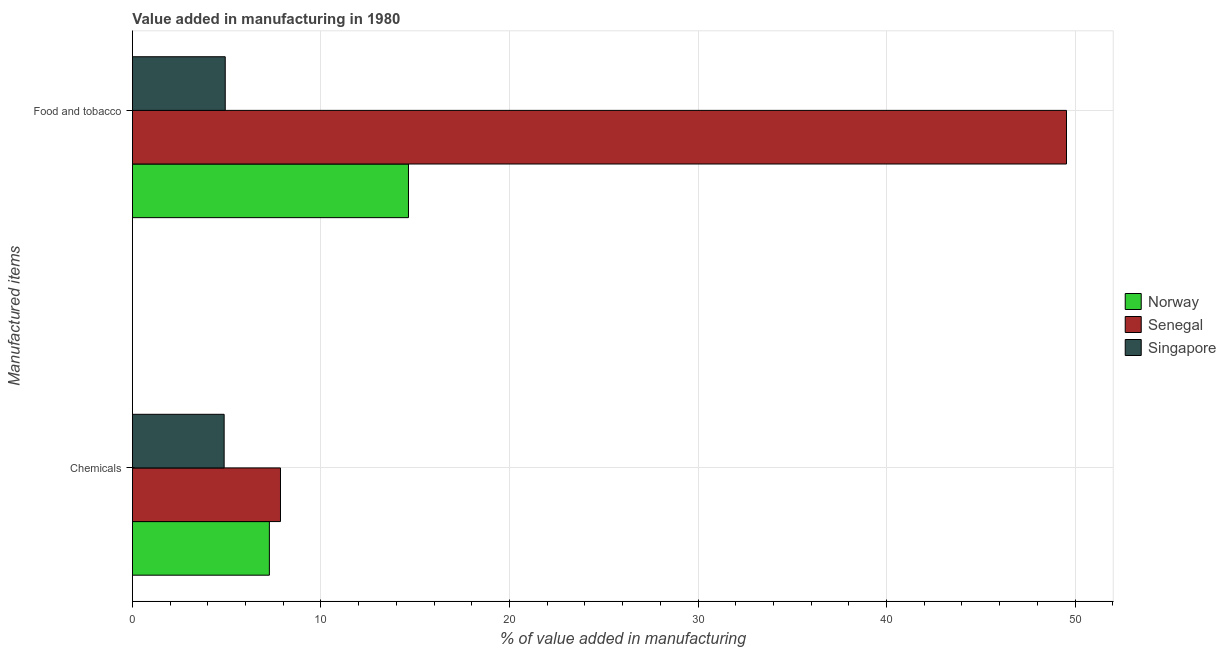How many groups of bars are there?
Your answer should be compact. 2. Are the number of bars per tick equal to the number of legend labels?
Give a very brief answer. Yes. What is the label of the 1st group of bars from the top?
Your answer should be compact. Food and tobacco. What is the value added by  manufacturing chemicals in Senegal?
Keep it short and to the point. 7.85. Across all countries, what is the maximum value added by manufacturing food and tobacco?
Provide a succinct answer. 49.54. Across all countries, what is the minimum value added by manufacturing food and tobacco?
Give a very brief answer. 4.92. In which country was the value added by  manufacturing chemicals maximum?
Ensure brevity in your answer.  Senegal. In which country was the value added by  manufacturing chemicals minimum?
Make the answer very short. Singapore. What is the total value added by manufacturing food and tobacco in the graph?
Offer a terse response. 69.11. What is the difference between the value added by  manufacturing chemicals in Senegal and that in Norway?
Provide a succinct answer. 0.59. What is the difference between the value added by manufacturing food and tobacco in Norway and the value added by  manufacturing chemicals in Singapore?
Your answer should be compact. 9.78. What is the average value added by  manufacturing chemicals per country?
Your response must be concise. 6.66. What is the difference between the value added by  manufacturing chemicals and value added by manufacturing food and tobacco in Norway?
Provide a succinct answer. -7.38. In how many countries, is the value added by manufacturing food and tobacco greater than 16 %?
Make the answer very short. 1. What is the ratio of the value added by  manufacturing chemicals in Singapore to that in Senegal?
Make the answer very short. 0.62. Is the value added by manufacturing food and tobacco in Norway less than that in Senegal?
Make the answer very short. Yes. What does the 2nd bar from the top in Food and tobacco represents?
Keep it short and to the point. Senegal. What does the 3rd bar from the bottom in Food and tobacco represents?
Your answer should be very brief. Singapore. How many bars are there?
Your response must be concise. 6. Are all the bars in the graph horizontal?
Make the answer very short. Yes. How many countries are there in the graph?
Provide a short and direct response. 3. What is the difference between two consecutive major ticks on the X-axis?
Provide a succinct answer. 10. Are the values on the major ticks of X-axis written in scientific E-notation?
Keep it short and to the point. No. Does the graph contain grids?
Provide a short and direct response. Yes. Where does the legend appear in the graph?
Provide a short and direct response. Center right. What is the title of the graph?
Make the answer very short. Value added in manufacturing in 1980. Does "St. Martin (French part)" appear as one of the legend labels in the graph?
Provide a short and direct response. No. What is the label or title of the X-axis?
Provide a short and direct response. % of value added in manufacturing. What is the label or title of the Y-axis?
Your answer should be very brief. Manufactured items. What is the % of value added in manufacturing in Norway in Chemicals?
Offer a terse response. 7.26. What is the % of value added in manufacturing in Senegal in Chemicals?
Ensure brevity in your answer.  7.85. What is the % of value added in manufacturing in Singapore in Chemicals?
Offer a very short reply. 4.86. What is the % of value added in manufacturing in Norway in Food and tobacco?
Give a very brief answer. 14.64. What is the % of value added in manufacturing in Senegal in Food and tobacco?
Provide a short and direct response. 49.54. What is the % of value added in manufacturing of Singapore in Food and tobacco?
Provide a succinct answer. 4.92. Across all Manufactured items, what is the maximum % of value added in manufacturing of Norway?
Your answer should be compact. 14.64. Across all Manufactured items, what is the maximum % of value added in manufacturing of Senegal?
Make the answer very short. 49.54. Across all Manufactured items, what is the maximum % of value added in manufacturing of Singapore?
Your answer should be compact. 4.92. Across all Manufactured items, what is the minimum % of value added in manufacturing in Norway?
Your response must be concise. 7.26. Across all Manufactured items, what is the minimum % of value added in manufacturing in Senegal?
Your answer should be very brief. 7.85. Across all Manufactured items, what is the minimum % of value added in manufacturing of Singapore?
Make the answer very short. 4.86. What is the total % of value added in manufacturing in Norway in the graph?
Offer a terse response. 21.9. What is the total % of value added in manufacturing of Senegal in the graph?
Ensure brevity in your answer.  57.4. What is the total % of value added in manufacturing in Singapore in the graph?
Make the answer very short. 9.79. What is the difference between the % of value added in manufacturing of Norway in Chemicals and that in Food and tobacco?
Give a very brief answer. -7.38. What is the difference between the % of value added in manufacturing in Senegal in Chemicals and that in Food and tobacco?
Keep it short and to the point. -41.69. What is the difference between the % of value added in manufacturing of Singapore in Chemicals and that in Food and tobacco?
Keep it short and to the point. -0.06. What is the difference between the % of value added in manufacturing of Norway in Chemicals and the % of value added in manufacturing of Senegal in Food and tobacco?
Provide a succinct answer. -42.28. What is the difference between the % of value added in manufacturing in Norway in Chemicals and the % of value added in manufacturing in Singapore in Food and tobacco?
Offer a terse response. 2.34. What is the difference between the % of value added in manufacturing of Senegal in Chemicals and the % of value added in manufacturing of Singapore in Food and tobacco?
Make the answer very short. 2.93. What is the average % of value added in manufacturing in Norway per Manufactured items?
Make the answer very short. 10.95. What is the average % of value added in manufacturing in Senegal per Manufactured items?
Offer a very short reply. 28.7. What is the average % of value added in manufacturing in Singapore per Manufactured items?
Your answer should be very brief. 4.89. What is the difference between the % of value added in manufacturing in Norway and % of value added in manufacturing in Senegal in Chemicals?
Offer a very short reply. -0.59. What is the difference between the % of value added in manufacturing of Norway and % of value added in manufacturing of Singapore in Chemicals?
Keep it short and to the point. 2.4. What is the difference between the % of value added in manufacturing of Senegal and % of value added in manufacturing of Singapore in Chemicals?
Your answer should be very brief. 2.99. What is the difference between the % of value added in manufacturing in Norway and % of value added in manufacturing in Senegal in Food and tobacco?
Give a very brief answer. -34.9. What is the difference between the % of value added in manufacturing of Norway and % of value added in manufacturing of Singapore in Food and tobacco?
Offer a very short reply. 9.72. What is the difference between the % of value added in manufacturing of Senegal and % of value added in manufacturing of Singapore in Food and tobacco?
Your response must be concise. 44.62. What is the ratio of the % of value added in manufacturing of Norway in Chemicals to that in Food and tobacco?
Offer a terse response. 0.5. What is the ratio of the % of value added in manufacturing of Senegal in Chemicals to that in Food and tobacco?
Make the answer very short. 0.16. What is the ratio of the % of value added in manufacturing of Singapore in Chemicals to that in Food and tobacco?
Keep it short and to the point. 0.99. What is the difference between the highest and the second highest % of value added in manufacturing in Norway?
Your answer should be very brief. 7.38. What is the difference between the highest and the second highest % of value added in manufacturing of Senegal?
Your answer should be very brief. 41.69. What is the difference between the highest and the second highest % of value added in manufacturing of Singapore?
Give a very brief answer. 0.06. What is the difference between the highest and the lowest % of value added in manufacturing in Norway?
Provide a short and direct response. 7.38. What is the difference between the highest and the lowest % of value added in manufacturing of Senegal?
Offer a very short reply. 41.69. What is the difference between the highest and the lowest % of value added in manufacturing of Singapore?
Provide a succinct answer. 0.06. 